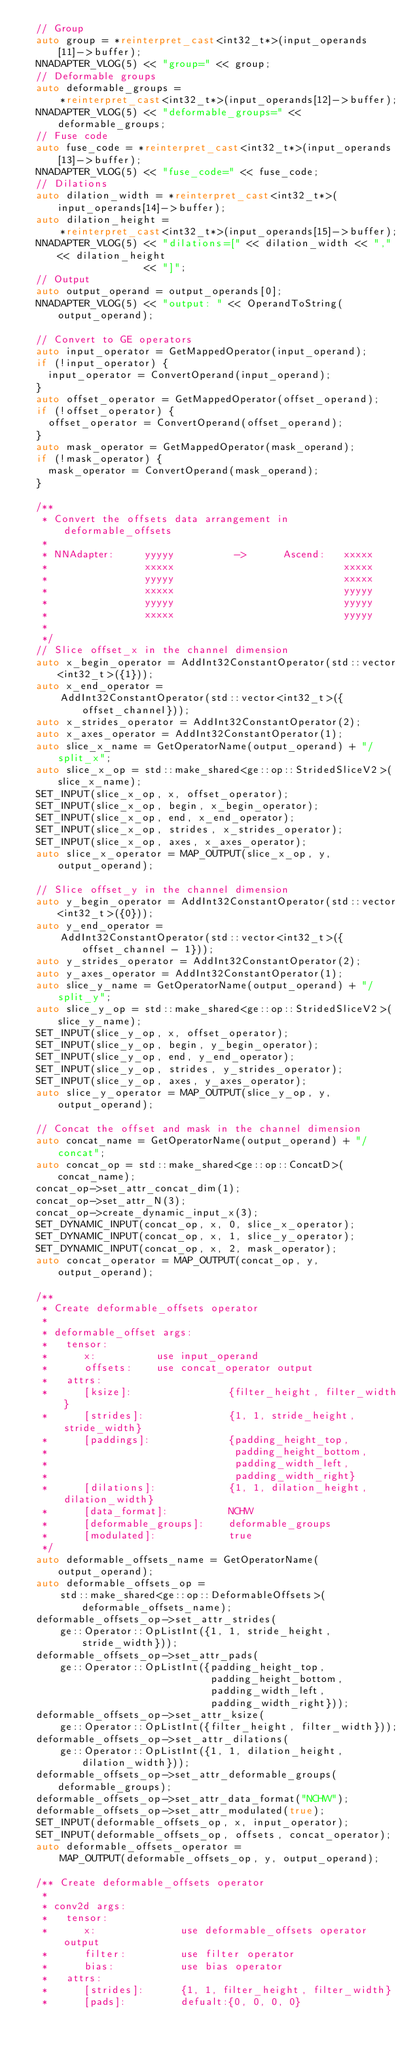<code> <loc_0><loc_0><loc_500><loc_500><_C++_>  // Group
  auto group = *reinterpret_cast<int32_t*>(input_operands[11]->buffer);
  NNADAPTER_VLOG(5) << "group=" << group;
  // Deformable groups
  auto deformable_groups =
      *reinterpret_cast<int32_t*>(input_operands[12]->buffer);
  NNADAPTER_VLOG(5) << "deformable_groups=" << deformable_groups;
  // Fuse code
  auto fuse_code = *reinterpret_cast<int32_t*>(input_operands[13]->buffer);
  NNADAPTER_VLOG(5) << "fuse_code=" << fuse_code;
  // Dilations
  auto dilation_width = *reinterpret_cast<int32_t*>(input_operands[14]->buffer);
  auto dilation_height =
      *reinterpret_cast<int32_t*>(input_operands[15]->buffer);
  NNADAPTER_VLOG(5) << "dilations=[" << dilation_width << "," << dilation_height
                    << "]";
  // Output
  auto output_operand = output_operands[0];
  NNADAPTER_VLOG(5) << "output: " << OperandToString(output_operand);

  // Convert to GE operators
  auto input_operator = GetMappedOperator(input_operand);
  if (!input_operator) {
    input_operator = ConvertOperand(input_operand);
  }
  auto offset_operator = GetMappedOperator(offset_operand);
  if (!offset_operator) {
    offset_operator = ConvertOperand(offset_operand);
  }
  auto mask_operator = GetMappedOperator(mask_operand);
  if (!mask_operator) {
    mask_operator = ConvertOperand(mask_operand);
  }

  /**
   * Convert the offsets data arrangement in deformable_offsets
   *
   * NNAdapter:     yyyyy          ->      Ascend:   xxxxx
   *                xxxxx                            xxxxx
   *                yyyyy                            xxxxx
   *                xxxxx                            yyyyy
   *                yyyyy                            yyyyy
   *                xxxxx                            yyyyy
   *
   */
  // Slice offset_x in the channel dimension
  auto x_begin_operator = AddInt32ConstantOperator(std::vector<int32_t>({1}));
  auto x_end_operator =
      AddInt32ConstantOperator(std::vector<int32_t>({offset_channel}));
  auto x_strides_operator = AddInt32ConstantOperator(2);
  auto x_axes_operator = AddInt32ConstantOperator(1);
  auto slice_x_name = GetOperatorName(output_operand) + "/split_x";
  auto slice_x_op = std::make_shared<ge::op::StridedSliceV2>(slice_x_name);
  SET_INPUT(slice_x_op, x, offset_operator);
  SET_INPUT(slice_x_op, begin, x_begin_operator);
  SET_INPUT(slice_x_op, end, x_end_operator);
  SET_INPUT(slice_x_op, strides, x_strides_operator);
  SET_INPUT(slice_x_op, axes, x_axes_operator);
  auto slice_x_operator = MAP_OUTPUT(slice_x_op, y, output_operand);

  // Slice offset_y in the channel dimension
  auto y_begin_operator = AddInt32ConstantOperator(std::vector<int32_t>({0}));
  auto y_end_operator =
      AddInt32ConstantOperator(std::vector<int32_t>({offset_channel - 1}));
  auto y_strides_operator = AddInt32ConstantOperator(2);
  auto y_axes_operator = AddInt32ConstantOperator(1);
  auto slice_y_name = GetOperatorName(output_operand) + "/split_y";
  auto slice_y_op = std::make_shared<ge::op::StridedSliceV2>(slice_y_name);
  SET_INPUT(slice_y_op, x, offset_operator);
  SET_INPUT(slice_y_op, begin, y_begin_operator);
  SET_INPUT(slice_y_op, end, y_end_operator);
  SET_INPUT(slice_y_op, strides, y_strides_operator);
  SET_INPUT(slice_y_op, axes, y_axes_operator);
  auto slice_y_operator = MAP_OUTPUT(slice_y_op, y, output_operand);

  // Concat the offset and mask in the channel dimension
  auto concat_name = GetOperatorName(output_operand) + "/concat";
  auto concat_op = std::make_shared<ge::op::ConcatD>(concat_name);
  concat_op->set_attr_concat_dim(1);
  concat_op->set_attr_N(3);
  concat_op->create_dynamic_input_x(3);
  SET_DYNAMIC_INPUT(concat_op, x, 0, slice_x_operator);
  SET_DYNAMIC_INPUT(concat_op, x, 1, slice_y_operator);
  SET_DYNAMIC_INPUT(concat_op, x, 2, mask_operator);
  auto concat_operator = MAP_OUTPUT(concat_op, y, output_operand);

  /**
   * Create deformable_offsets operator
   *
   * deformable_offset args:
   *   tensor:
   *      x:          use input_operand
   *      offsets:    use concat_operator output
   *   attrs:
   *      [ksize]:                {filter_height, filter_width}
   *      [strides]:              {1, 1, stride_height, stride_width}
   *      [paddings]:             {padding_height_top,
   *                               padding_height_bottom,
   *                               padding_width_left,
   *                               padding_width_right}
   *      [dilations]:            {1, 1, dilation_height, dilation_width}
   *      [data_format]:          NCHW
   *      [deformable_groups]:    deformable_groups
   *      [modulated]:            true
   */
  auto deformable_offsets_name = GetOperatorName(output_operand);
  auto deformable_offsets_op =
      std::make_shared<ge::op::DeformableOffsets>(deformable_offsets_name);
  deformable_offsets_op->set_attr_strides(
      ge::Operator::OpListInt({1, 1, stride_height, stride_width}));
  deformable_offsets_op->set_attr_pads(
      ge::Operator::OpListInt({padding_height_top,
                               padding_height_bottom,
                               padding_width_left,
                               padding_width_right}));
  deformable_offsets_op->set_attr_ksize(
      ge::Operator::OpListInt({filter_height, filter_width}));
  deformable_offsets_op->set_attr_dilations(
      ge::Operator::OpListInt({1, 1, dilation_height, dilation_width}));
  deformable_offsets_op->set_attr_deformable_groups(deformable_groups);
  deformable_offsets_op->set_attr_data_format("NCHW");
  deformable_offsets_op->set_attr_modulated(true);
  SET_INPUT(deformable_offsets_op, x, input_operator);
  SET_INPUT(deformable_offsets_op, offsets, concat_operator);
  auto deformable_offsets_operator =
      MAP_OUTPUT(deformable_offsets_op, y, output_operand);

  /** Create deformable_offsets operator
   *
   * conv2d args:
   *   tensor:
   *      x:              use deformable_offsets operator output
   *      filter:         use filter operator
   *      bias:           use bias operator
   *   attrs:
   *      [strides]:      {1, 1, filter_height, filter_width}
   *      [pads]:         defualt:{0, 0, 0, 0}</code> 